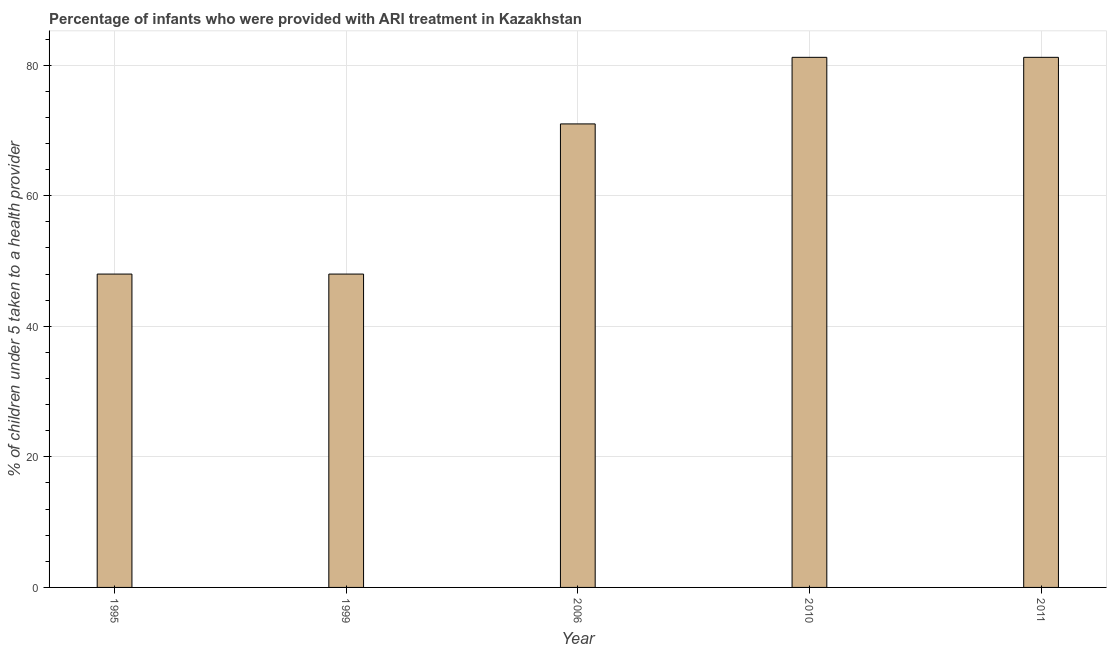What is the title of the graph?
Offer a very short reply. Percentage of infants who were provided with ARI treatment in Kazakhstan. What is the label or title of the X-axis?
Your answer should be compact. Year. What is the label or title of the Y-axis?
Ensure brevity in your answer.  % of children under 5 taken to a health provider. Across all years, what is the maximum percentage of children who were provided with ari treatment?
Your answer should be compact. 81.2. Across all years, what is the minimum percentage of children who were provided with ari treatment?
Your answer should be very brief. 48. In which year was the percentage of children who were provided with ari treatment maximum?
Ensure brevity in your answer.  2010. What is the sum of the percentage of children who were provided with ari treatment?
Make the answer very short. 329.4. What is the difference between the percentage of children who were provided with ari treatment in 1999 and 2006?
Your answer should be very brief. -23. What is the average percentage of children who were provided with ari treatment per year?
Make the answer very short. 65.88. In how many years, is the percentage of children who were provided with ari treatment greater than 12 %?
Ensure brevity in your answer.  5. What is the ratio of the percentage of children who were provided with ari treatment in 2006 to that in 2010?
Make the answer very short. 0.87. Is the sum of the percentage of children who were provided with ari treatment in 1995 and 1999 greater than the maximum percentage of children who were provided with ari treatment across all years?
Keep it short and to the point. Yes. What is the difference between the highest and the lowest percentage of children who were provided with ari treatment?
Provide a short and direct response. 33.2. In how many years, is the percentage of children who were provided with ari treatment greater than the average percentage of children who were provided with ari treatment taken over all years?
Make the answer very short. 3. Are the values on the major ticks of Y-axis written in scientific E-notation?
Provide a short and direct response. No. What is the % of children under 5 taken to a health provider of 1999?
Offer a very short reply. 48. What is the % of children under 5 taken to a health provider of 2010?
Give a very brief answer. 81.2. What is the % of children under 5 taken to a health provider of 2011?
Offer a very short reply. 81.2. What is the difference between the % of children under 5 taken to a health provider in 1995 and 2010?
Make the answer very short. -33.2. What is the difference between the % of children under 5 taken to a health provider in 1995 and 2011?
Your response must be concise. -33.2. What is the difference between the % of children under 5 taken to a health provider in 1999 and 2006?
Ensure brevity in your answer.  -23. What is the difference between the % of children under 5 taken to a health provider in 1999 and 2010?
Your answer should be compact. -33.2. What is the difference between the % of children under 5 taken to a health provider in 1999 and 2011?
Make the answer very short. -33.2. What is the difference between the % of children under 5 taken to a health provider in 2006 and 2011?
Provide a short and direct response. -10.2. What is the ratio of the % of children under 5 taken to a health provider in 1995 to that in 1999?
Make the answer very short. 1. What is the ratio of the % of children under 5 taken to a health provider in 1995 to that in 2006?
Ensure brevity in your answer.  0.68. What is the ratio of the % of children under 5 taken to a health provider in 1995 to that in 2010?
Provide a short and direct response. 0.59. What is the ratio of the % of children under 5 taken to a health provider in 1995 to that in 2011?
Offer a very short reply. 0.59. What is the ratio of the % of children under 5 taken to a health provider in 1999 to that in 2006?
Keep it short and to the point. 0.68. What is the ratio of the % of children under 5 taken to a health provider in 1999 to that in 2010?
Your answer should be very brief. 0.59. What is the ratio of the % of children under 5 taken to a health provider in 1999 to that in 2011?
Offer a very short reply. 0.59. What is the ratio of the % of children under 5 taken to a health provider in 2006 to that in 2010?
Keep it short and to the point. 0.87. What is the ratio of the % of children under 5 taken to a health provider in 2006 to that in 2011?
Your answer should be very brief. 0.87. 